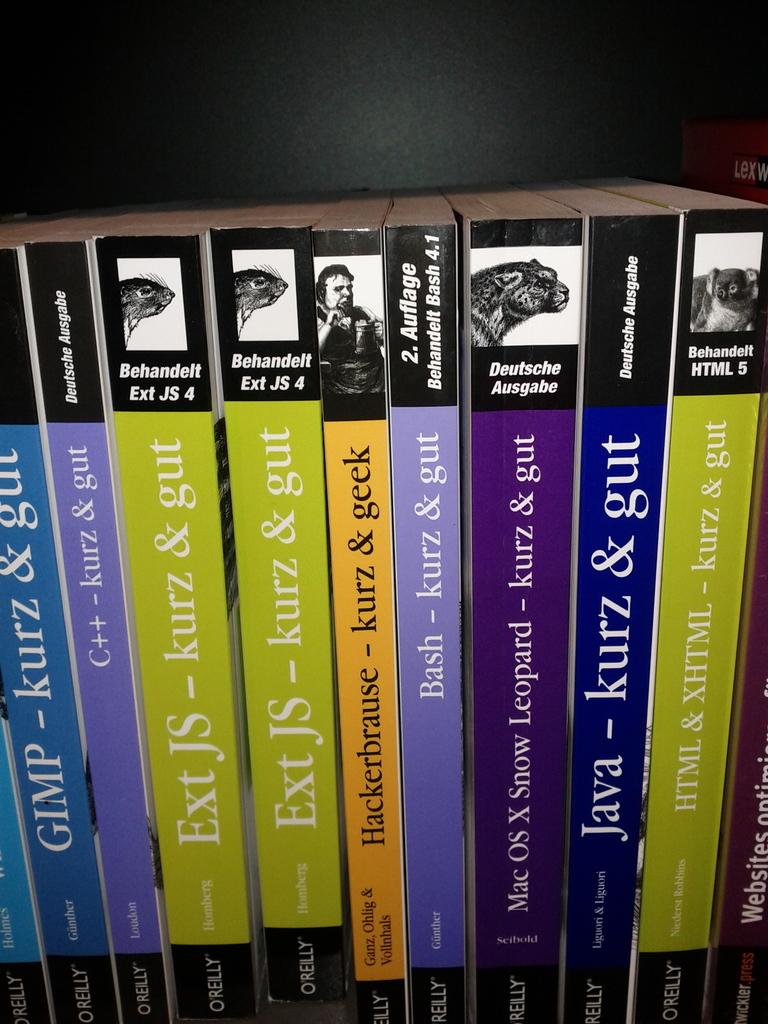What's the title of the book to the very left?
Your answer should be very brief. Gimp. 